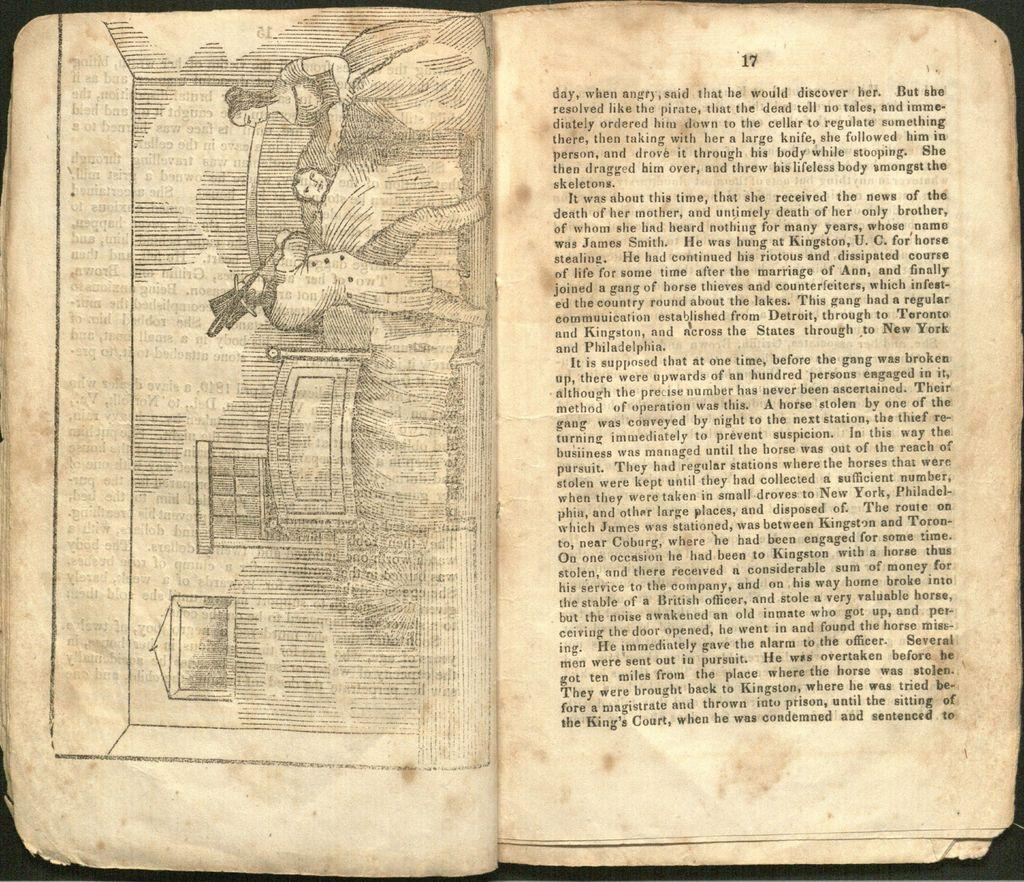Provide a one-sentence caption for the provided image. old open book with a drawing on the left page and right page is on page 17. 